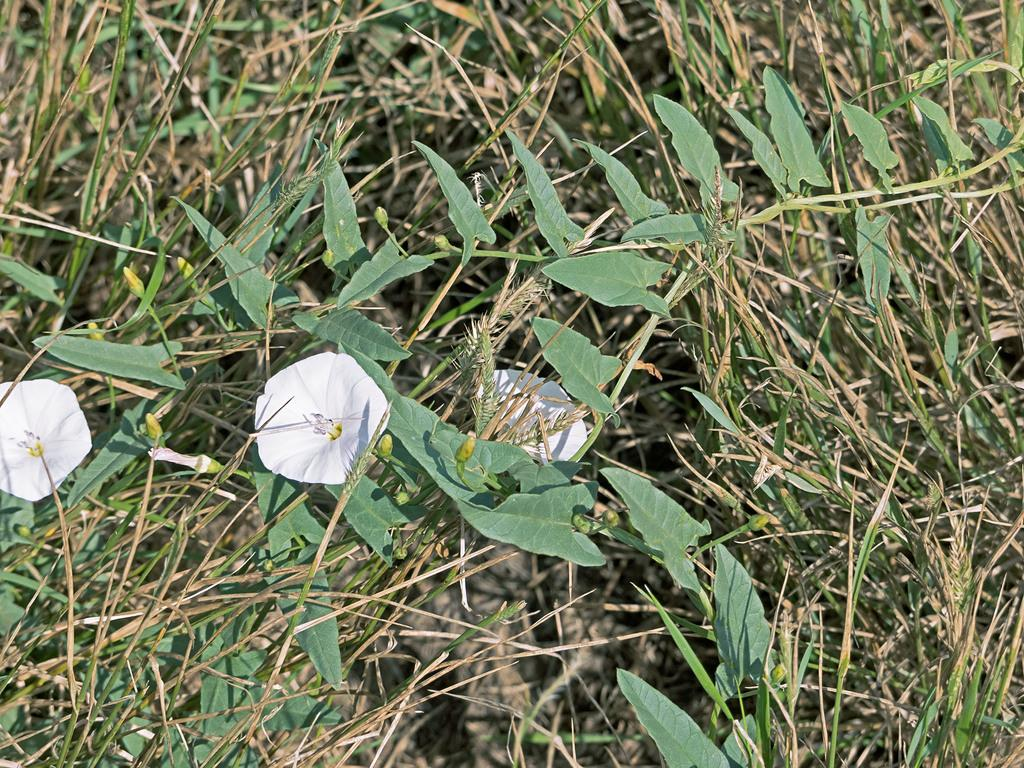What type of flora can be seen in the image? There are flowers and plants in the image. What colors are the flowers in the image? The flowers are in white and yellow colors. What color are the plants in the image? The plants are in green color. What type of zebra can be seen grazing on the plants in the image? There is no zebra present in the image; it only features flowers and plants. 